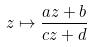<formula> <loc_0><loc_0><loc_500><loc_500>z \mapsto \frac { a z + b } { c z + d }</formula> 